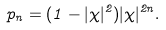Convert formula to latex. <formula><loc_0><loc_0><loc_500><loc_500>p _ { n } = ( 1 - | \chi | ^ { 2 } ) | \chi | ^ { 2 n } .</formula> 